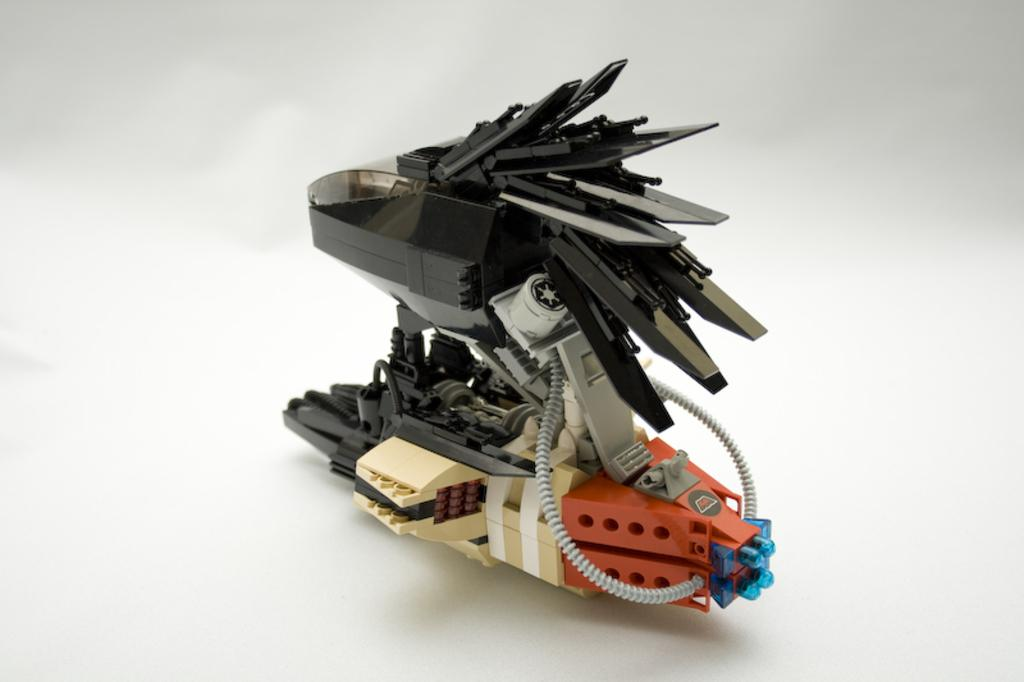What is the main object in the image? There is a toy in the image. What is the toy placed on? The toy is on a white color object. What type of rock can be seen in the image? There is no rock present in the image; it features a toy on a white color object. What type of school is depicted in the image? There is no school present in the image; it features a toy on a white color object. 